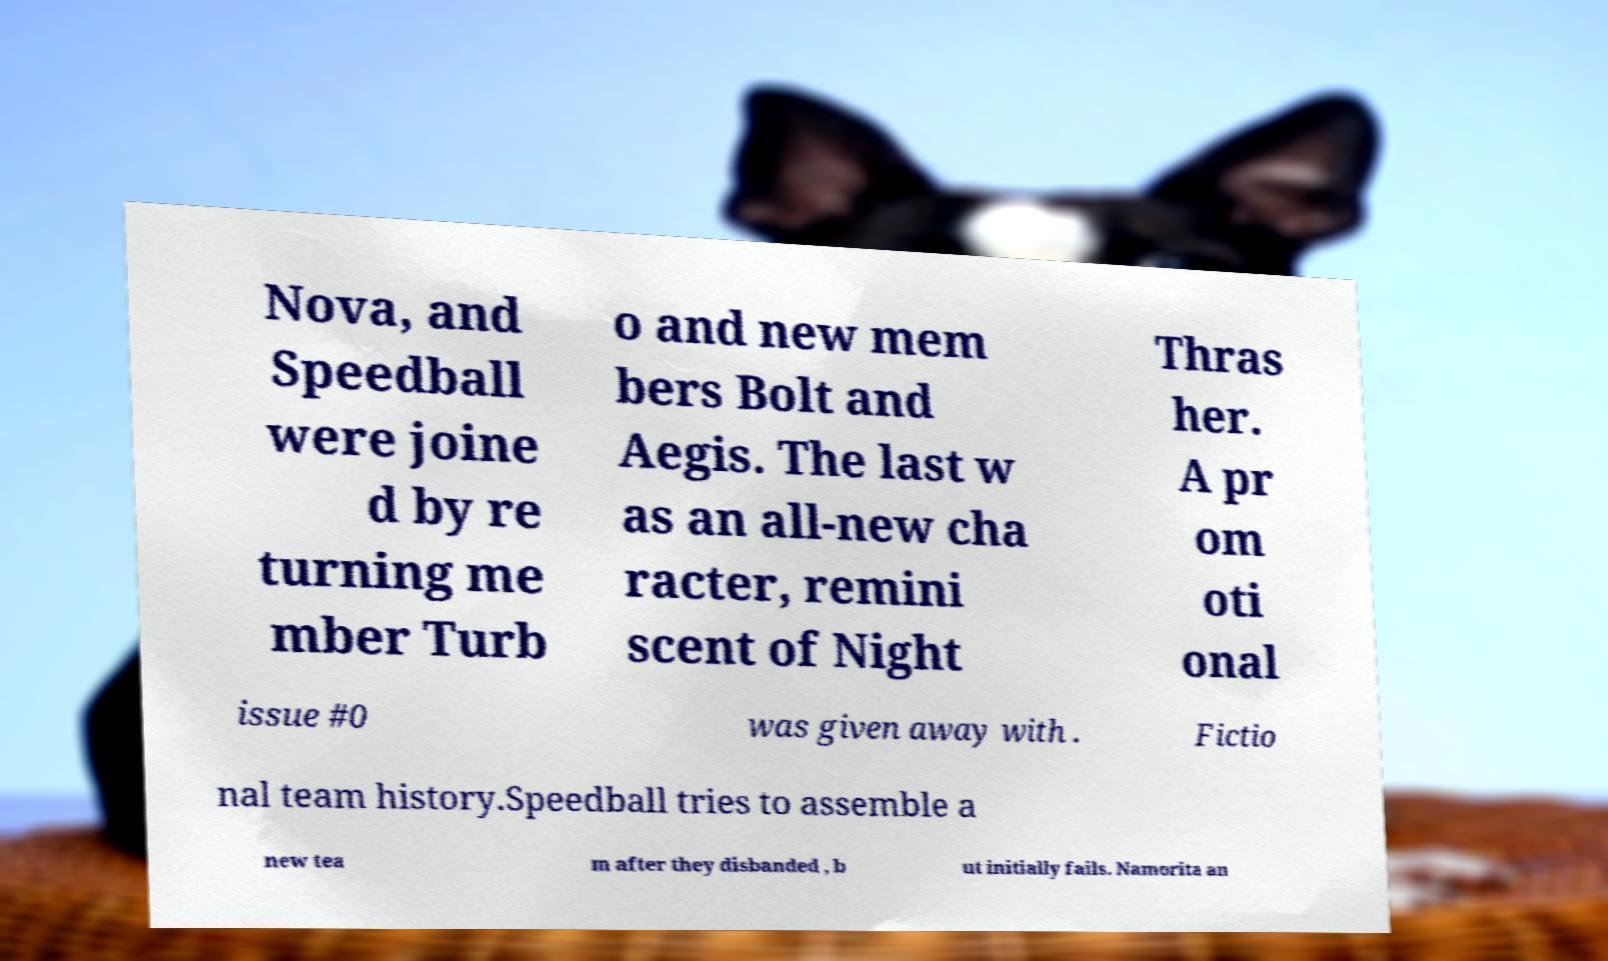Please identify and transcribe the text found in this image. Nova, and Speedball were joine d by re turning me mber Turb o and new mem bers Bolt and Aegis. The last w as an all-new cha racter, remini scent of Night Thras her. A pr om oti onal issue #0 was given away with . Fictio nal team history.Speedball tries to assemble a new tea m after they disbanded , b ut initially fails. Namorita an 